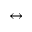<formula> <loc_0><loc_0><loc_500><loc_500>\leftrightarrow</formula> 